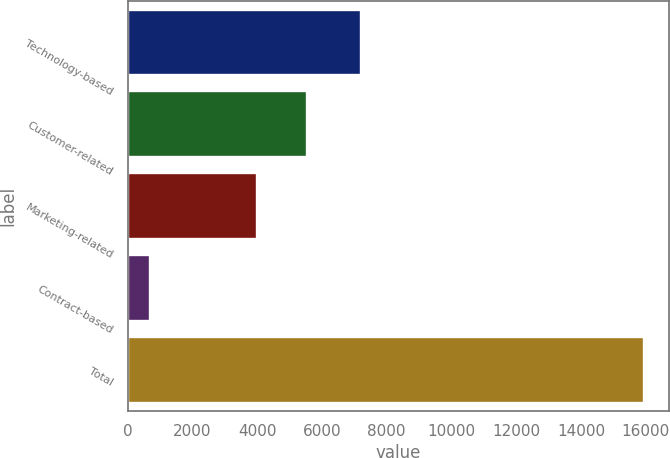<chart> <loc_0><loc_0><loc_500><loc_500><bar_chart><fcel>Technology-based<fcel>Customer-related<fcel>Marketing-related<fcel>Contract-based<fcel>Total<nl><fcel>7220<fcel>5531.7<fcel>4006<fcel>679<fcel>15936<nl></chart> 